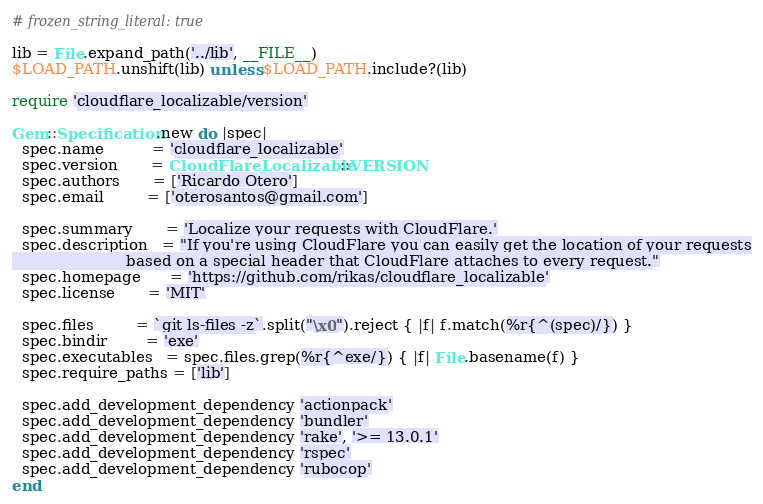<code> <loc_0><loc_0><loc_500><loc_500><_Ruby_># frozen_string_literal: true

lib = File.expand_path('../lib', __FILE__)
$LOAD_PATH.unshift(lib) unless $LOAD_PATH.include?(lib)

require 'cloudflare_localizable/version'

Gem::Specification.new do |spec|
  spec.name          = 'cloudflare_localizable'
  spec.version       = CloudFlareLocalizable::VERSION
  spec.authors       = ['Ricardo Otero']
  spec.email         = ['oterosantos@gmail.com']

  spec.summary       = 'Localize your requests with CloudFlare.'
  spec.description   = "If you're using CloudFlare you can easily get the location of your requests
                        based on a special header that CloudFlare attaches to every request."
  spec.homepage      = 'https://github.com/rikas/cloudflare_localizable'
  spec.license       = 'MIT'

  spec.files         = `git ls-files -z`.split("\x0").reject { |f| f.match(%r{^(spec)/}) }
  spec.bindir        = 'exe'
  spec.executables   = spec.files.grep(%r{^exe/}) { |f| File.basename(f) }
  spec.require_paths = ['lib']

  spec.add_development_dependency 'actionpack'
  spec.add_development_dependency 'bundler'
  spec.add_development_dependency 'rake', '>= 13.0.1'
  spec.add_development_dependency 'rspec'
  spec.add_development_dependency 'rubocop'
end
</code> 